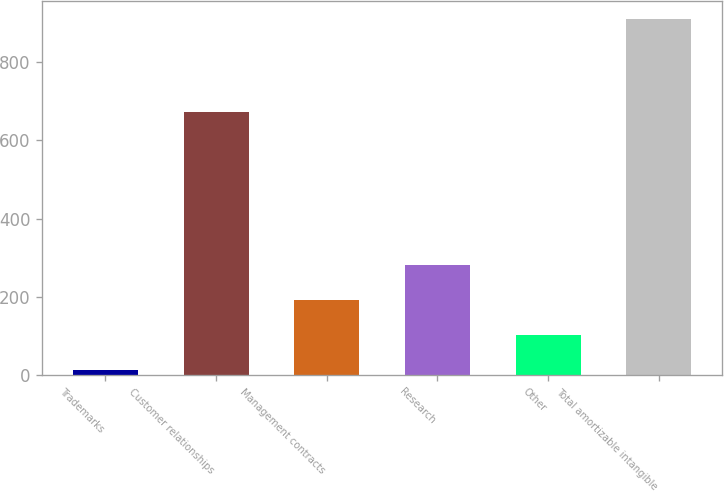Convert chart to OTSL. <chart><loc_0><loc_0><loc_500><loc_500><bar_chart><fcel>Trademarks<fcel>Customer relationships<fcel>Management contracts<fcel>Research<fcel>Other<fcel>Total amortizable intangible<nl><fcel>13<fcel>673<fcel>192.4<fcel>282.1<fcel>102.7<fcel>910<nl></chart> 